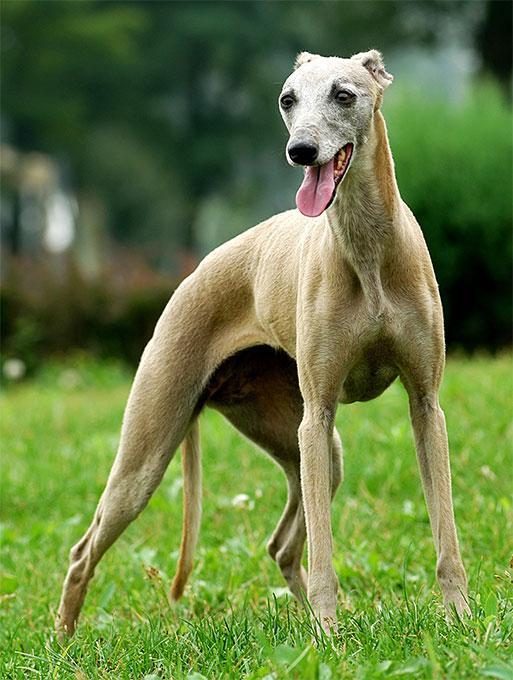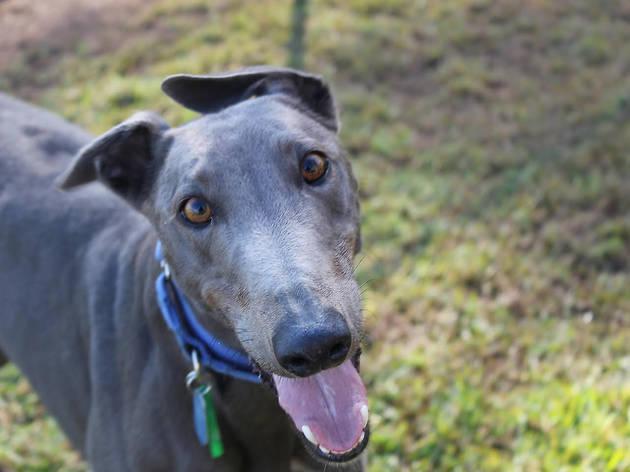The first image is the image on the left, the second image is the image on the right. Evaluate the accuracy of this statement regarding the images: "The dog's legs are not visible in one of the images.". Is it true? Answer yes or no. Yes. 